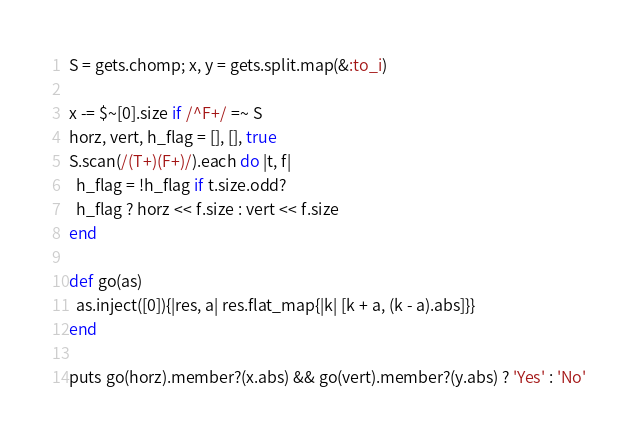<code> <loc_0><loc_0><loc_500><loc_500><_Ruby_>S = gets.chomp; x, y = gets.split.map(&:to_i)

x -= $~[0].size if /^F+/ =~ S
horz, vert, h_flag = [], [], true
S.scan(/(T+)(F+)/).each do |t, f|
  h_flag = !h_flag if t.size.odd?
  h_flag ? horz << f.size : vert << f.size
end

def go(as)
  as.inject([0]){|res, a| res.flat_map{|k| [k + a, (k - a).abs]}}
end

puts go(horz).member?(x.abs) && go(vert).member?(y.abs) ? 'Yes' : 'No'</code> 